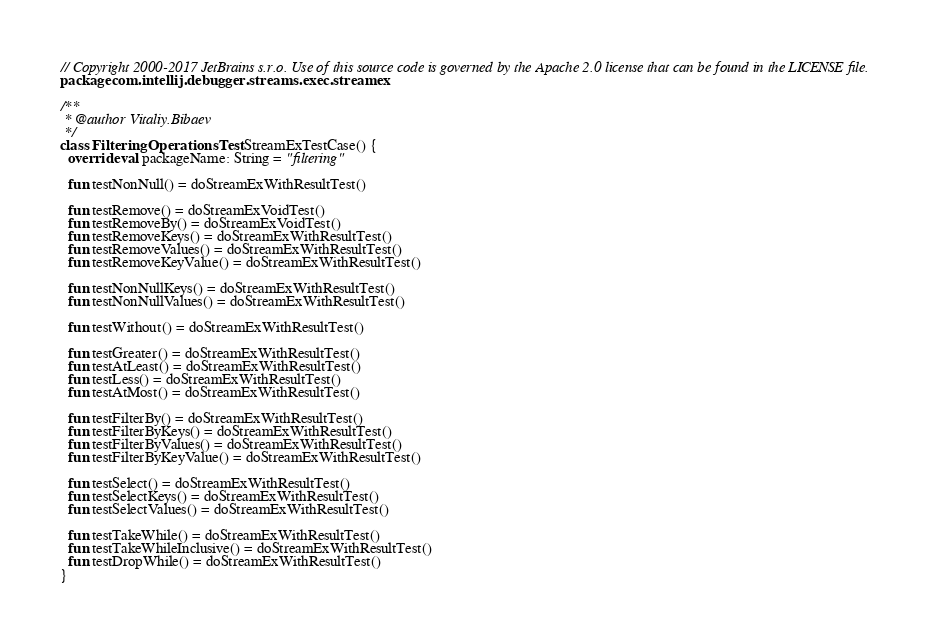Convert code to text. <code><loc_0><loc_0><loc_500><loc_500><_Kotlin_>// Copyright 2000-2017 JetBrains s.r.o. Use of this source code is governed by the Apache 2.0 license that can be found in the LICENSE file.
package com.intellij.debugger.streams.exec.streamex

/**
 * @author Vitaliy.Bibaev
 */
class FilteringOperationsTest : StreamExTestCase() {
  override val packageName: String = "filtering"

  fun testNonNull() = doStreamExWithResultTest()

  fun testRemove() = doStreamExVoidTest()
  fun testRemoveBy() = doStreamExVoidTest()
  fun testRemoveKeys() = doStreamExWithResultTest()
  fun testRemoveValues() = doStreamExWithResultTest()
  fun testRemoveKeyValue() = doStreamExWithResultTest()

  fun testNonNullKeys() = doStreamExWithResultTest()
  fun testNonNullValues() = doStreamExWithResultTest()

  fun testWithout() = doStreamExWithResultTest()

  fun testGreater() = doStreamExWithResultTest()
  fun testAtLeast() = doStreamExWithResultTest()
  fun testLess() = doStreamExWithResultTest()
  fun testAtMost() = doStreamExWithResultTest()

  fun testFilterBy() = doStreamExWithResultTest()
  fun testFilterByKeys() = doStreamExWithResultTest()
  fun testFilterByValues() = doStreamExWithResultTest()
  fun testFilterByKeyValue() = doStreamExWithResultTest()

  fun testSelect() = doStreamExWithResultTest()
  fun testSelectKeys() = doStreamExWithResultTest()
  fun testSelectValues() = doStreamExWithResultTest()

  fun testTakeWhile() = doStreamExWithResultTest()
  fun testTakeWhileInclusive() = doStreamExWithResultTest()
  fun testDropWhile() = doStreamExWithResultTest()
}</code> 